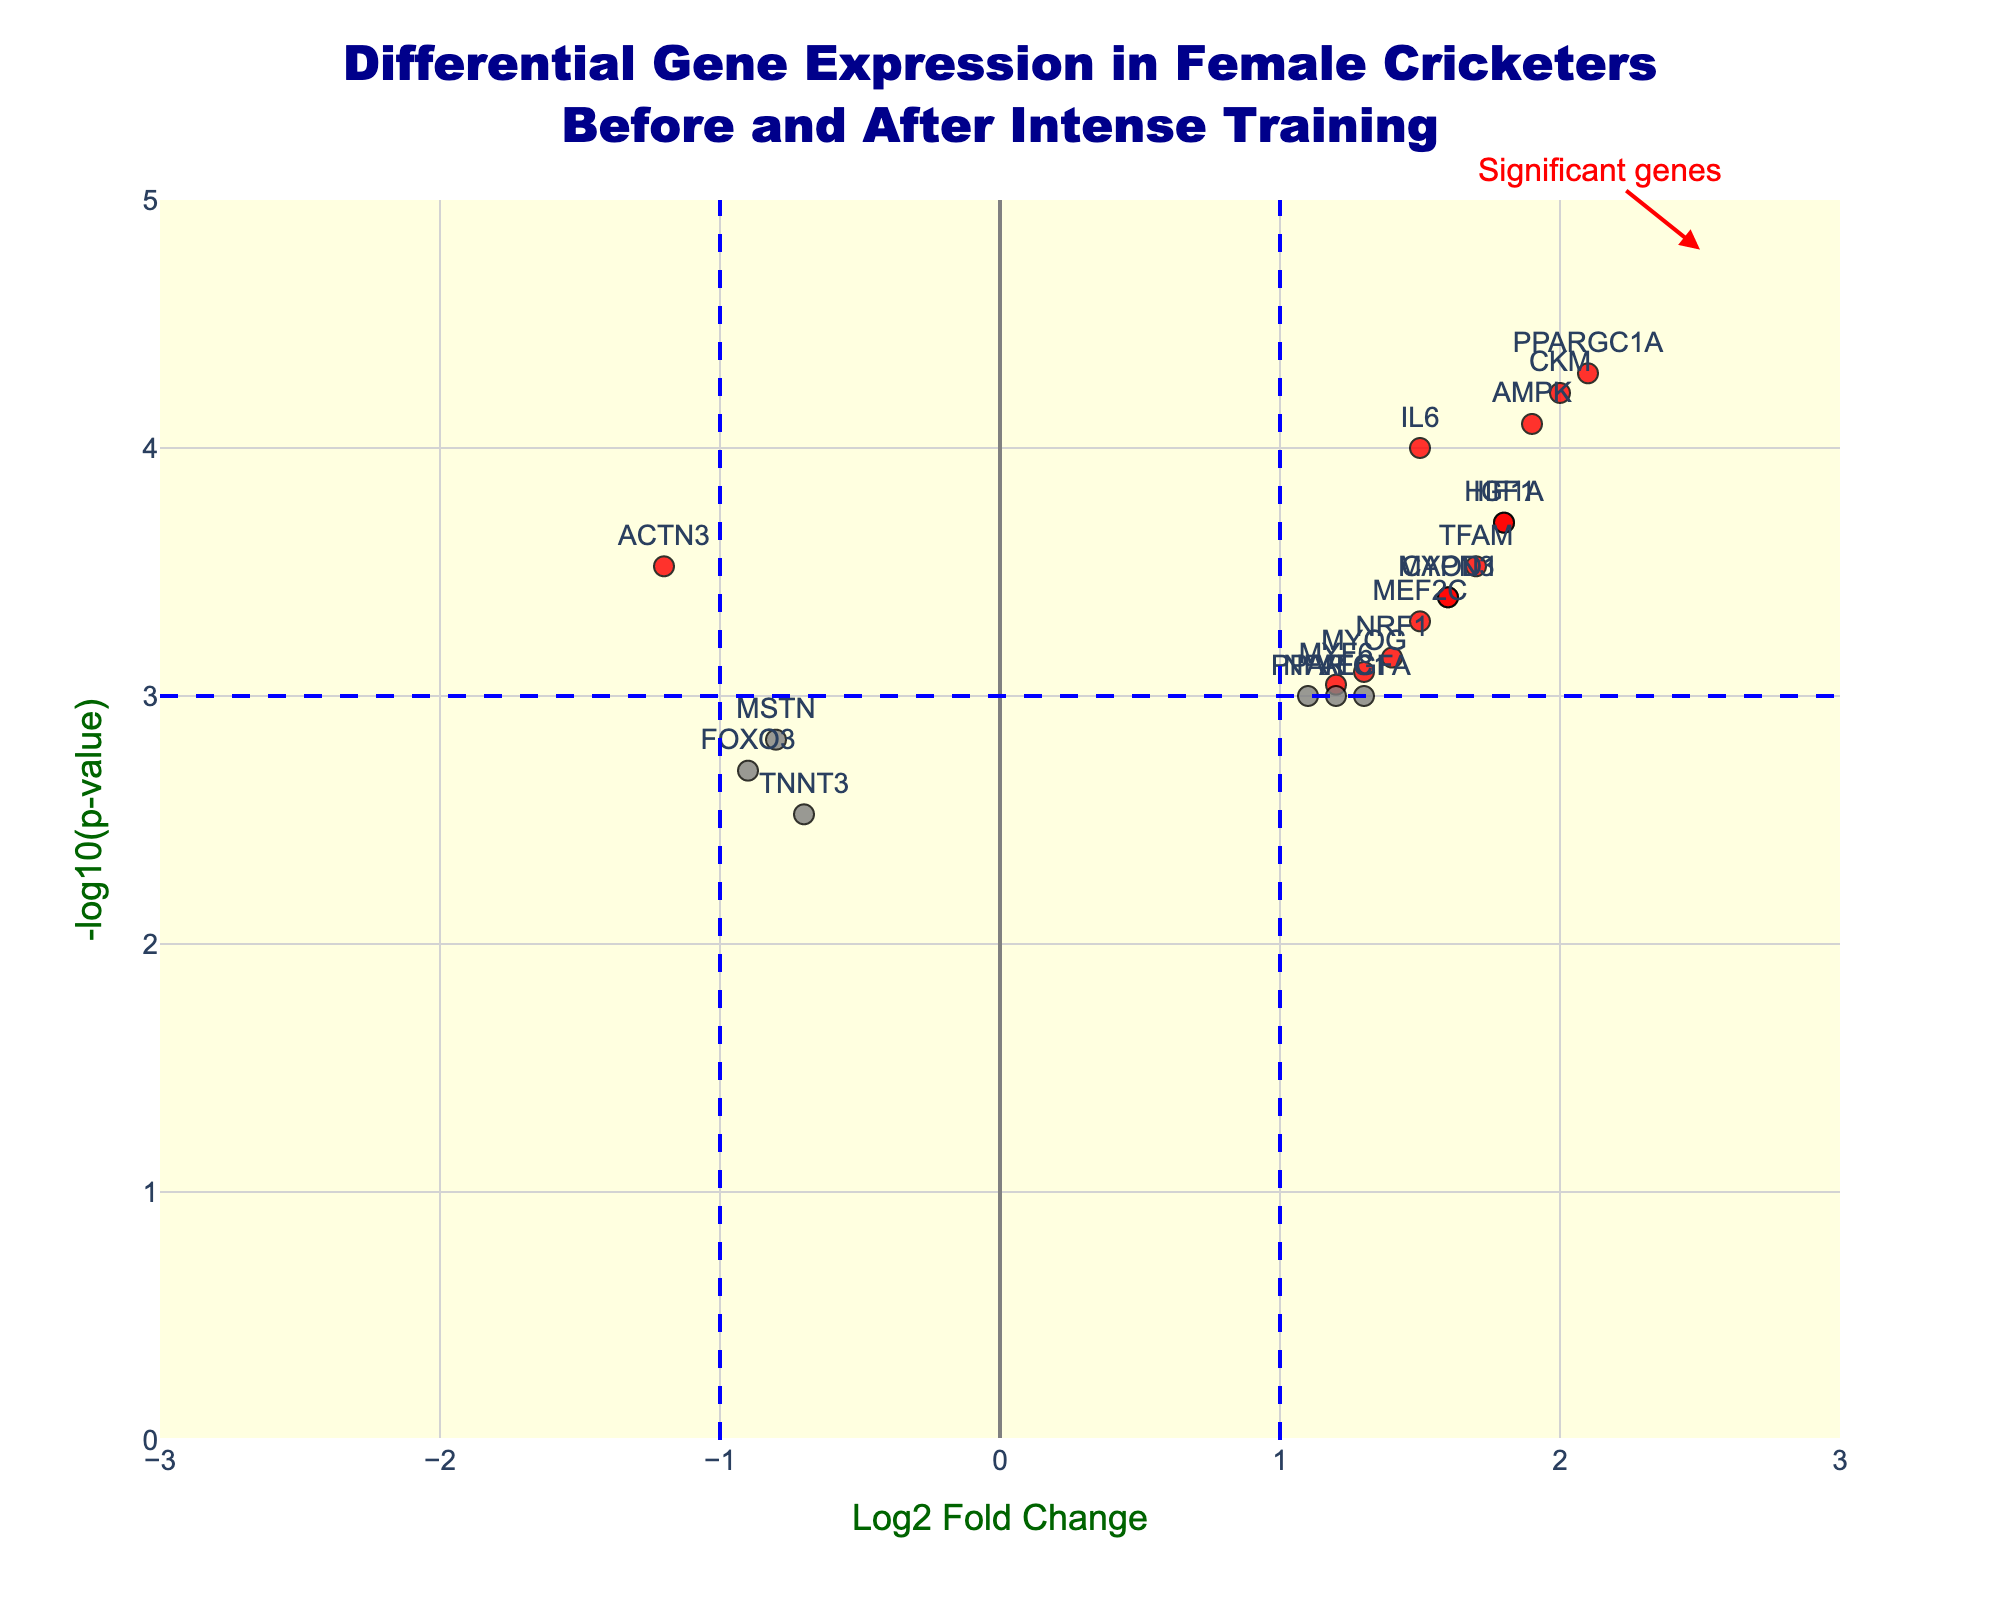How many genes are labeled as significant in the plot? The significant genes are those with a Log2 Fold Change greater than 1 in absolute terms and a p-value less than 0.001, which are marked in red on the plot. From the table, these genes are PPARGC1A, IGF1, AMPK, HIF1A, and CKM.
Answer: 5 Which gene shows the highest upregulation? The upregulated genes have a positive Log2 Fold Change. Among the upregulated genes, the one with the highest Log2 Fold Change is PPARGC1A with a value of 2.1.
Answer: PPARGC1A Which gene shows the highest downregulation? The downregulated genes have a negative Log2 Fold Change. Among the downregulated genes, the one with the lowest (most negative) Log2 Fold Change is ACTN3 with a value of -1.2.
Answer: ACTN3 What is the p-value threshold indicated by the horizontal blue line on the plot? The horizontal blue line on the plot represents the threshold for the p-value, which is 0.001. This is calculated as -log10(0.001) which equals 3.
Answer: 0.001 (shown as 3 in log scale) Identify a gene that is upregulated with a p-value less than 0.001 but not red-colored. By looking at the upregulated genes, we find that VEGFA has a positive Log2 Fold Change (1.3) and a p-value (0.001), which is right at the threshold hence it is grey-colored on the plot.
Answer: VEGFA Which genes related to muscle growth have higher expression levels after intense training? Genes related to muscle growth include MYOD1, IGF1, TFAM, MYF6, MEF2C, and MYOG. Those with positive Log2 Fold Change and red color have higher expression levels. These genes are MYOD1, IGF1, TFAM, and MYF6.
Answer: MYOD1, IGF1, TFAM, MYF6 Is IL6 significantly upregulated? IL6 has a Log2 Fold Change of 1.5 and a p-value of 0.0001. The Log2 Fold Change is greater than 1 and the p-value is less than 0.001, and it is marked red, confirming its significant upregulation.
Answer: Yes Which gene has the smallest p-value and is it upregulated or downregulated? The gene with the smallest p-value is PPARGC1A (0.00005). It has a positive Log2 Fold Change (2.1) indicating it is upregulated.
Answer: PPARGC1A, upregulated How many genes are labelled around -1 Log2 Fold Change? By observing the plot, we can see there are genes, ACTN3 (-1.2), MSTN (-0.8), FOXO3 (-0.9), and TNNT3 (-0.7), all in the vicinity of -1 Log2 Fold Change.
Answer: 4 